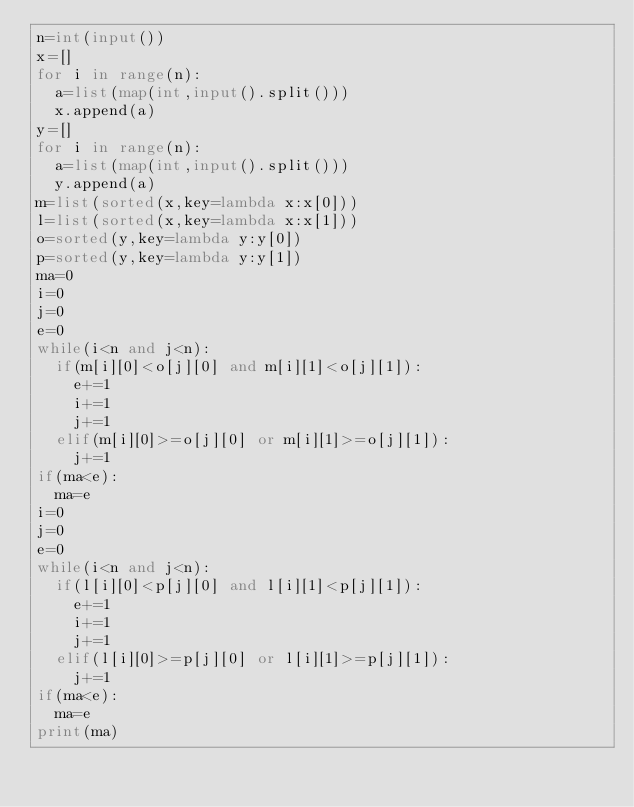<code> <loc_0><loc_0><loc_500><loc_500><_Python_>n=int(input())
x=[]
for i in range(n):
	a=list(map(int,input().split()))
	x.append(a)
y=[]
for i in range(n):
	a=list(map(int,input().split()))
	y.append(a)
m=list(sorted(x,key=lambda x:x[0]))
l=list(sorted(x,key=lambda x:x[1]))
o=sorted(y,key=lambda y:y[0])
p=sorted(y,key=lambda y:y[1])
ma=0
i=0
j=0
e=0
while(i<n and j<n):
	if(m[i][0]<o[j][0] and m[i][1]<o[j][1]):
		e+=1
		i+=1
		j+=1
	elif(m[i][0]>=o[j][0] or m[i][1]>=o[j][1]):
		j+=1
if(ma<e):
	ma=e
i=0
j=0
e=0
while(i<n and j<n):
	if(l[i][0]<p[j][0] and l[i][1]<p[j][1]):
		e+=1
		i+=1
		j+=1
	elif(l[i][0]>=p[j][0] or l[i][1]>=p[j][1]):
		j+=1
if(ma<e):
	ma=e
print(ma)
</code> 